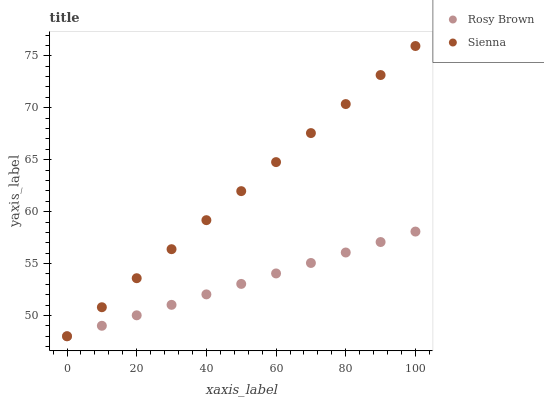Does Rosy Brown have the minimum area under the curve?
Answer yes or no. Yes. Does Sienna have the maximum area under the curve?
Answer yes or no. Yes. Does Rosy Brown have the maximum area under the curve?
Answer yes or no. No. Is Rosy Brown the smoothest?
Answer yes or no. Yes. Is Sienna the roughest?
Answer yes or no. Yes. Is Rosy Brown the roughest?
Answer yes or no. No. Does Sienna have the lowest value?
Answer yes or no. Yes. Does Sienna have the highest value?
Answer yes or no. Yes. Does Rosy Brown have the highest value?
Answer yes or no. No. Does Rosy Brown intersect Sienna?
Answer yes or no. Yes. Is Rosy Brown less than Sienna?
Answer yes or no. No. Is Rosy Brown greater than Sienna?
Answer yes or no. No. 